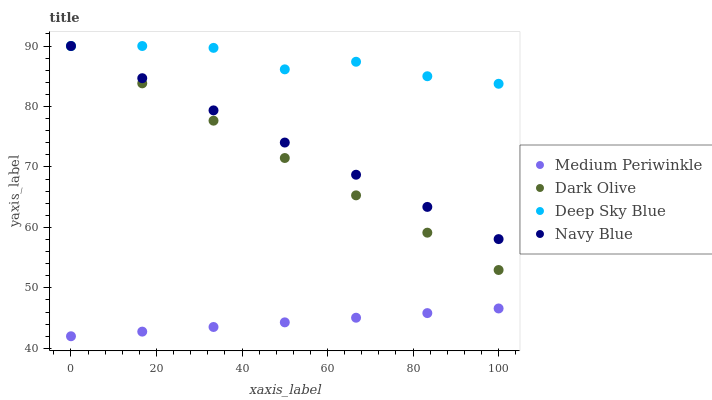Does Medium Periwinkle have the minimum area under the curve?
Answer yes or no. Yes. Does Deep Sky Blue have the maximum area under the curve?
Answer yes or no. Yes. Does Dark Olive have the minimum area under the curve?
Answer yes or no. No. Does Dark Olive have the maximum area under the curve?
Answer yes or no. No. Is Medium Periwinkle the smoothest?
Answer yes or no. Yes. Is Deep Sky Blue the roughest?
Answer yes or no. Yes. Is Dark Olive the smoothest?
Answer yes or no. No. Is Dark Olive the roughest?
Answer yes or no. No. Does Medium Periwinkle have the lowest value?
Answer yes or no. Yes. Does Dark Olive have the lowest value?
Answer yes or no. No. Does Deep Sky Blue have the highest value?
Answer yes or no. Yes. Does Medium Periwinkle have the highest value?
Answer yes or no. No. Is Medium Periwinkle less than Deep Sky Blue?
Answer yes or no. Yes. Is Navy Blue greater than Medium Periwinkle?
Answer yes or no. Yes. Does Navy Blue intersect Dark Olive?
Answer yes or no. Yes. Is Navy Blue less than Dark Olive?
Answer yes or no. No. Is Navy Blue greater than Dark Olive?
Answer yes or no. No. Does Medium Periwinkle intersect Deep Sky Blue?
Answer yes or no. No. 